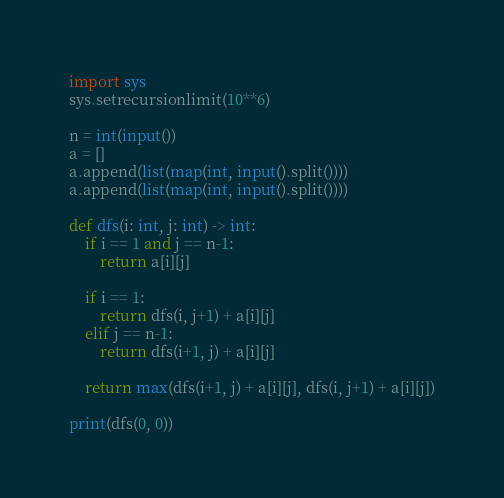<code> <loc_0><loc_0><loc_500><loc_500><_Python_>import sys
sys.setrecursionlimit(10**6)

n = int(input())
a = []
a.append(list(map(int, input().split())))
a.append(list(map(int, input().split())))

def dfs(i: int, j: int) -> int:
    if i == 1 and j == n-1:
        return a[i][j]

    if i == 1:
        return dfs(i, j+1) + a[i][j]
    elif j == n-1:
        return dfs(i+1, j) + a[i][j]

    return max(dfs(i+1, j) + a[i][j], dfs(i, j+1) + a[i][j])

print(dfs(0, 0))
</code> 